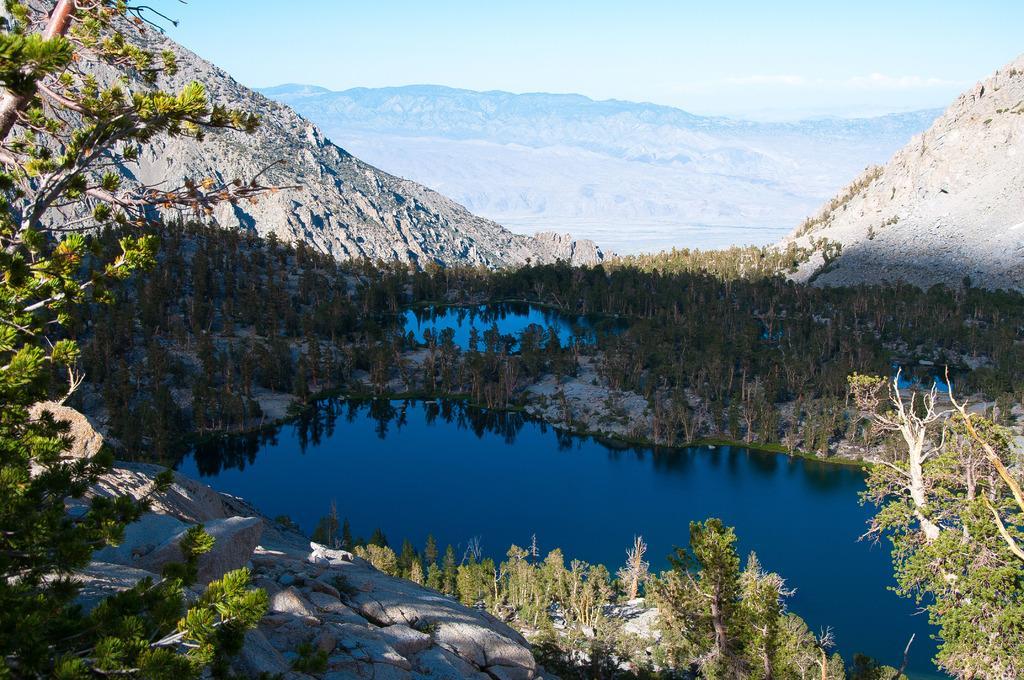How would you summarize this image in a sentence or two? It is the picture of beautiful scenery there are many plants, mountains, a river and also a pond. 